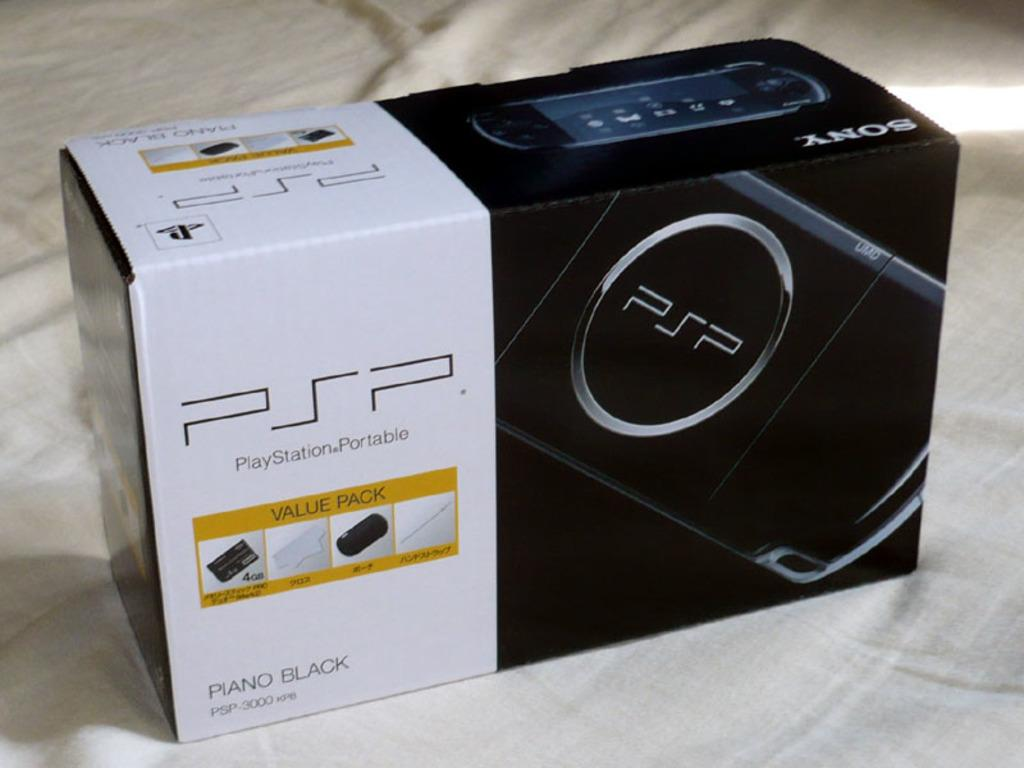<image>
Give a short and clear explanation of the subsequent image. A Sony box that contains a piano black PSP 3000 system 